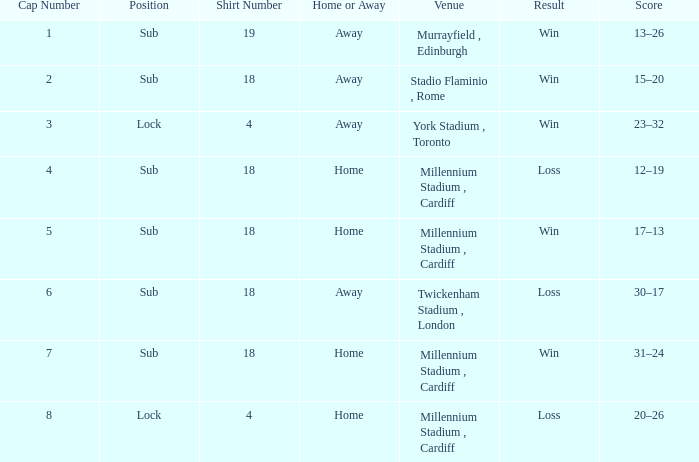Can you tell me the Score that has the Result of win, and the Date of 13 november 2009? 17–13. 